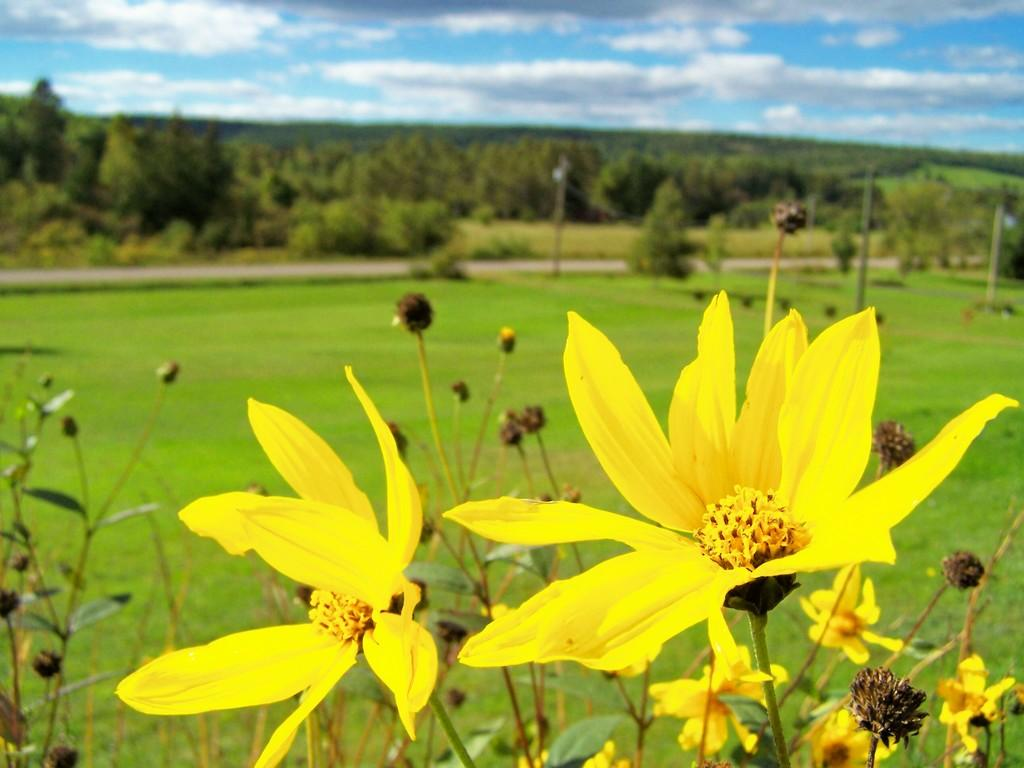What type of living organisms can be seen in the image? Plants with flowers and buds and buds are visible in the image. What can be seen in the background of the image? There is a grassland, a road, trees, and the sky visible in the background of the image. How is the image quality? The image is blurred. What type of pump is visible in the image? There is no pump present in the image. What kind of toy can be seen in the image? There is no toy present in the image. 